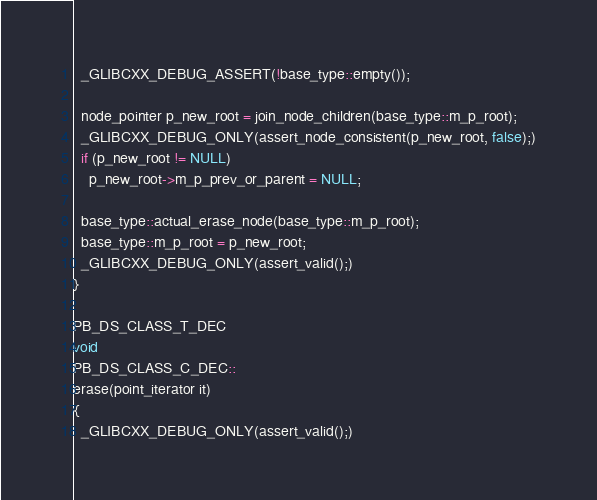Convert code to text. <code><loc_0><loc_0><loc_500><loc_500><_C++_>  _GLIBCXX_DEBUG_ASSERT(!base_type::empty());

  node_pointer p_new_root = join_node_children(base_type::m_p_root);
  _GLIBCXX_DEBUG_ONLY(assert_node_consistent(p_new_root, false);)
  if (p_new_root != NULL)
    p_new_root->m_p_prev_or_parent = NULL;

  base_type::actual_erase_node(base_type::m_p_root);
  base_type::m_p_root = p_new_root;
  _GLIBCXX_DEBUG_ONLY(assert_valid();)
}

PB_DS_CLASS_T_DEC
void
PB_DS_CLASS_C_DEC::
erase(point_iterator it)
{
  _GLIBCXX_DEBUG_ONLY(assert_valid();)</code> 